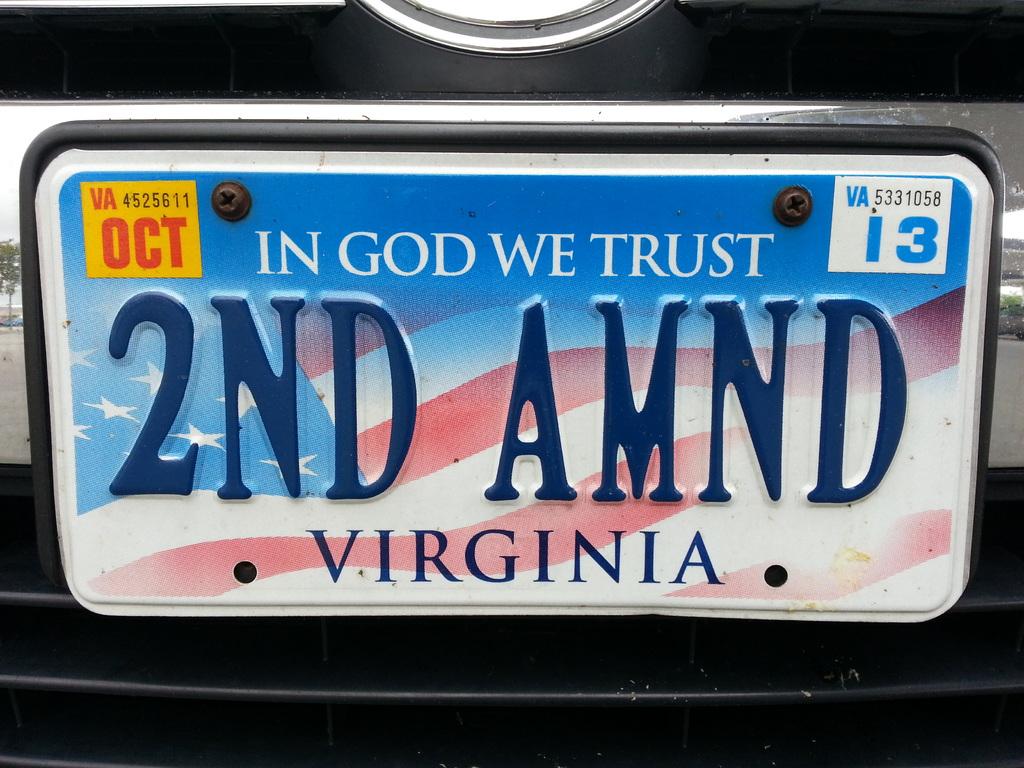What is the motto on this license plate?
Ensure brevity in your answer.  In god we trust. Which state issued the license plate?
Offer a terse response. Virginia. 